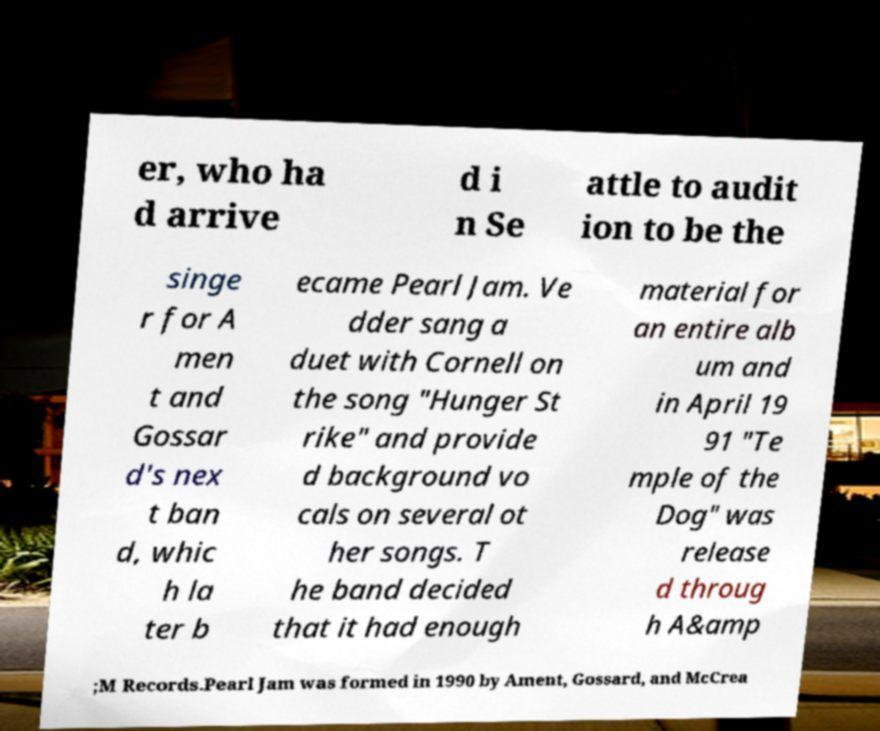Please identify and transcribe the text found in this image. er, who ha d arrive d i n Se attle to audit ion to be the singe r for A men t and Gossar d's nex t ban d, whic h la ter b ecame Pearl Jam. Ve dder sang a duet with Cornell on the song "Hunger St rike" and provide d background vo cals on several ot her songs. T he band decided that it had enough material for an entire alb um and in April 19 91 "Te mple of the Dog" was release d throug h A&amp ;M Records.Pearl Jam was formed in 1990 by Ament, Gossard, and McCrea 